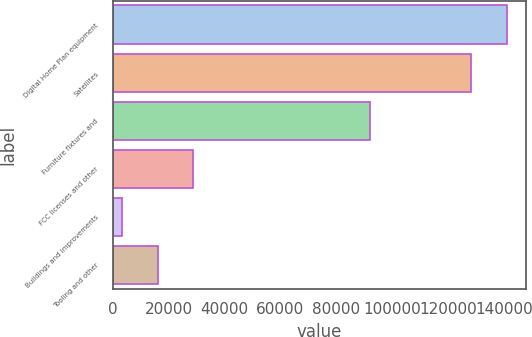Convert chart. <chart><loc_0><loc_0><loc_500><loc_500><bar_chart><fcel>Digital Home Plan equipment<fcel>Satellites<fcel>Furniture fixtures and<fcel>FCC licenses and other<fcel>Buildings and improvements<fcel>Tooling and other<nl><fcel>140891<fcel>128155<fcel>92180<fcel>28871.2<fcel>3399<fcel>16135.1<nl></chart> 